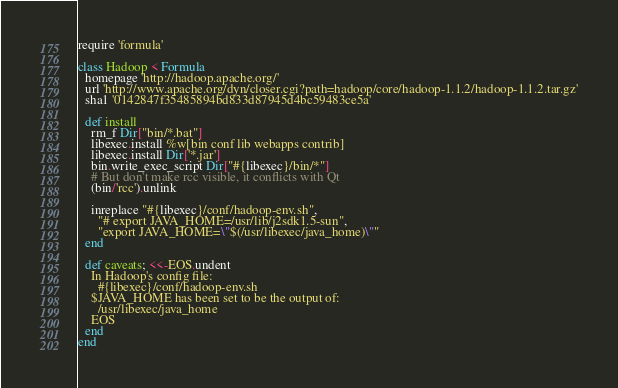<code> <loc_0><loc_0><loc_500><loc_500><_Ruby_>require 'formula'

class Hadoop < Formula
  homepage 'http://hadoop.apache.org/'
  url 'http://www.apache.org/dyn/closer.cgi?path=hadoop/core/hadoop-1.1.2/hadoop-1.1.2.tar.gz'
  sha1 '0142847f35485894bd833d87945d4bc59483ce5a'

  def install
    rm_f Dir["bin/*.bat"]
    libexec.install %w[bin conf lib webapps contrib]
    libexec.install Dir['*.jar']
    bin.write_exec_script Dir["#{libexec}/bin/*"]
    # But don't make rcc visible, it conflicts with Qt
    (bin/'rcc').unlink

    inreplace "#{libexec}/conf/hadoop-env.sh",
      "# export JAVA_HOME=/usr/lib/j2sdk1.5-sun",
      "export JAVA_HOME=\"$(/usr/libexec/java_home)\""
  end

  def caveats; <<-EOS.undent
    In Hadoop's config file:
      #{libexec}/conf/hadoop-env.sh
    $JAVA_HOME has been set to be the output of:
      /usr/libexec/java_home
    EOS
  end
end
</code> 